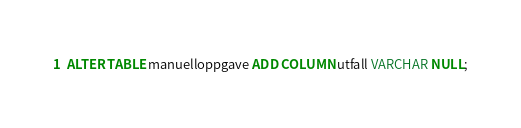Convert code to text. <code><loc_0><loc_0><loc_500><loc_500><_SQL_>ALTER TABLE manuelloppgave ADD COLUMN utfall VARCHAR NULL;</code> 